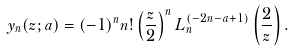<formula> <loc_0><loc_0><loc_500><loc_500>y _ { n } ( z ; a ) = ( - 1 ) ^ { n } n ! \left ( \frac { z } { 2 } \right ) ^ { n } L _ { n } ^ { ( - 2 n - a + 1 ) } \left ( \frac { 2 } { z } \right ) .</formula> 